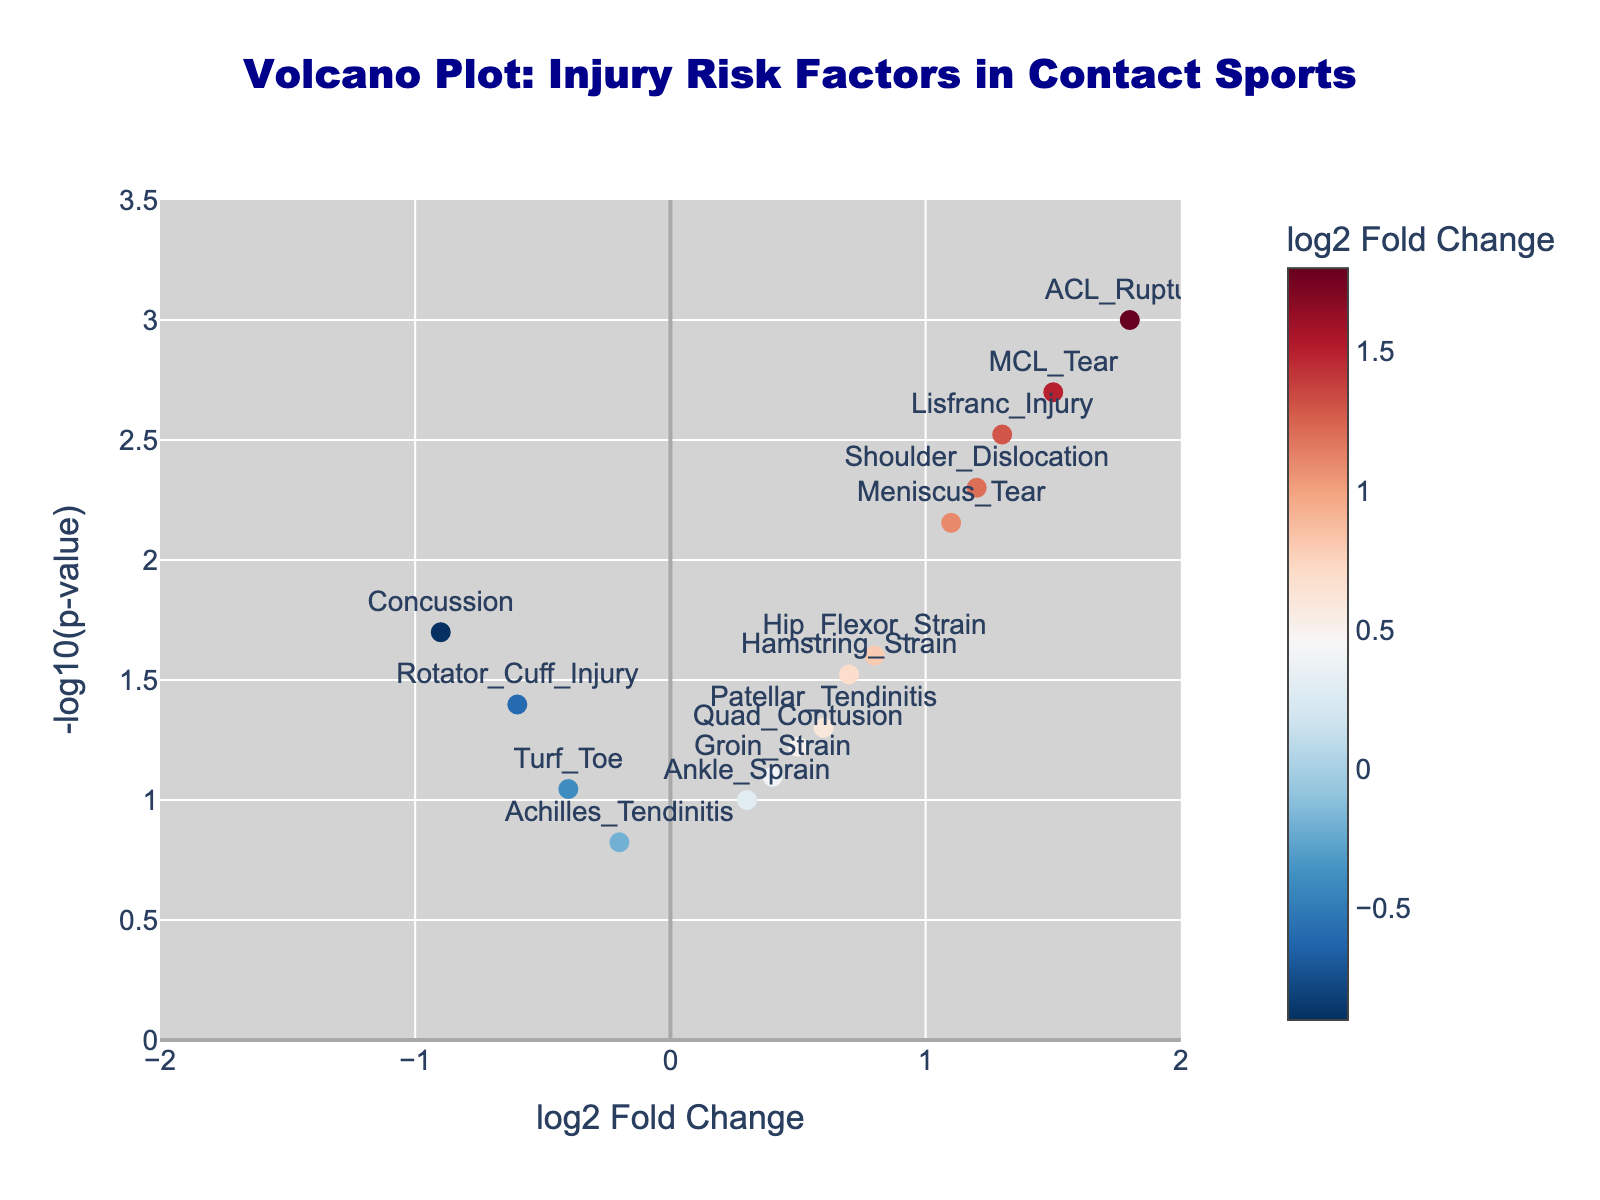How many injury risk factors have a p-value less than 0.01? Count the data points where the p-value converted to -log10(pvalue) exceeds 2 (since -log10(0.01) = 2). There are 6 such points.
Answer: 6 What is the title of the plot? The title is given in the layout of the plot.
Answer: Volcano Plot: Injury Risk Factors in Contact Sports Which injury has the highest log2 fold change value? Look at the x-axis to find the injury with the highest log2 fold change value. ACL_Rupture at 1.8 is the highest.
Answer: ACL_Rupture Which injury has the lowest log2 fold change value? Look at the x-axis to find the injury with the lowest log2 fold change value. Concussion at -0.9 is the lowest.
Answer: Concussion What is the log2 fold change value for Patellar_Tendinitis? Find the data point labeled Patellar_Tendinitis and read its x-axis value, which is 0.6.
Answer: 0.6 How many injury risk factors have a negative log2 fold change? Count the number of injury risk factors with log2 fold change values less than 0. There are 3 such points.
Answer: 3 Which injury risk factor has the highest significance (lowest p-value)? Look for the data point with the highest -log10(pvalue), which corresponds to the lowest p-value. ACL_Rupture at 3 (-log10(0.001)) is the most significant.
Answer: ACL_Rupture Which injuries have a log2 fold change value greater than 1? Identify the injuries with log2 fold change values greater than 1 by examining the x-axis. There are ACL_Rupture, Shoulder_Dislocation, MCL_Tear, Lisfranc_Injury.
Answer: ACL_Rupture, Shoulder_Dislocation, MCL_Tear, Lisfranc_Injury What is the range of the y-axis? The range is defined in the figure layout, which is from 0 to 3.5 for -log10(p-value).
Answer: 0 to 3.5 Is there an injury risk factor that has both a positive log2 fold change and a high p-value (insignificant)? Look for points on the plot's right side with a low y-axis value (indicating a high p-value). Ankle_Sprain at (0.3, 1) qualifies.
Answer: Ankle_Sprain 